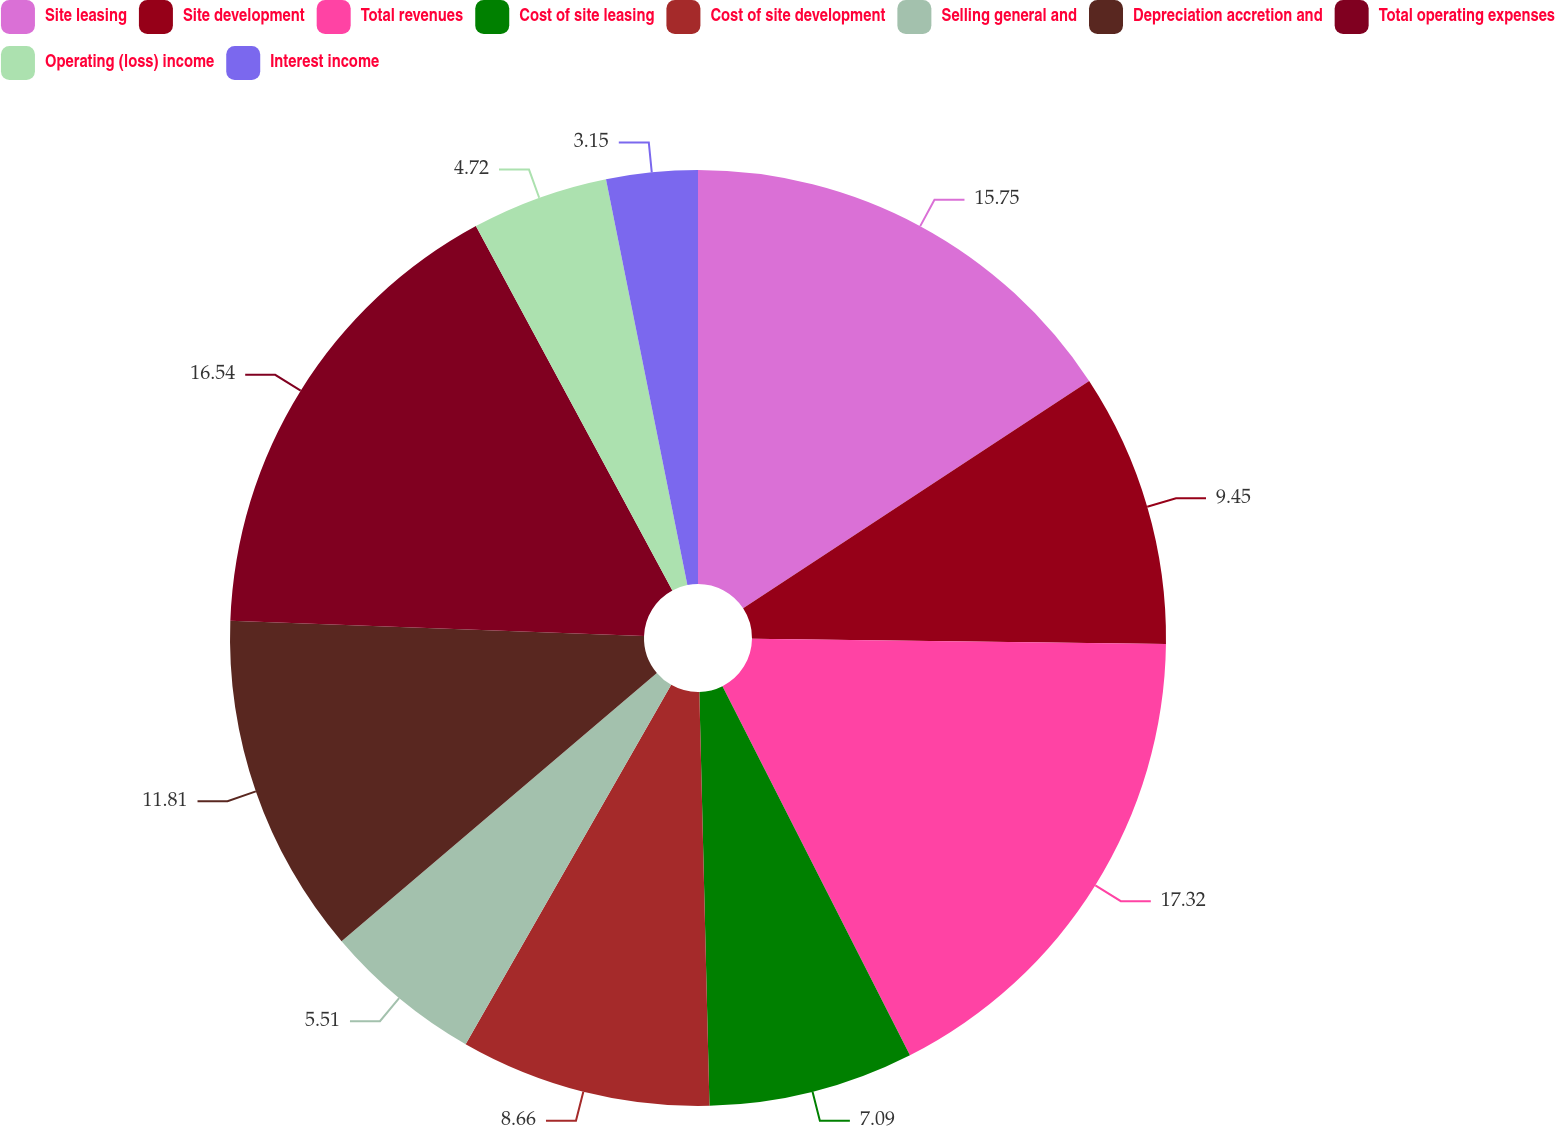Convert chart. <chart><loc_0><loc_0><loc_500><loc_500><pie_chart><fcel>Site leasing<fcel>Site development<fcel>Total revenues<fcel>Cost of site leasing<fcel>Cost of site development<fcel>Selling general and<fcel>Depreciation accretion and<fcel>Total operating expenses<fcel>Operating (loss) income<fcel>Interest income<nl><fcel>15.75%<fcel>9.45%<fcel>17.32%<fcel>7.09%<fcel>8.66%<fcel>5.51%<fcel>11.81%<fcel>16.54%<fcel>4.72%<fcel>3.15%<nl></chart> 